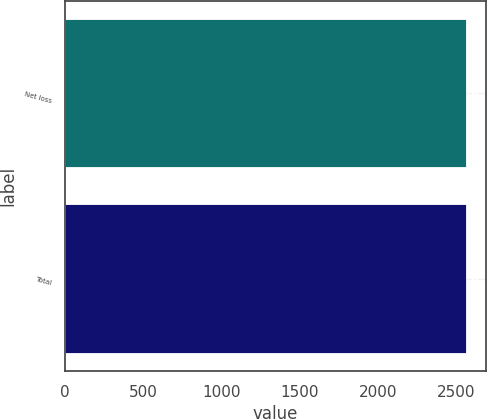Convert chart to OTSL. <chart><loc_0><loc_0><loc_500><loc_500><bar_chart><fcel>Net loss<fcel>Total<nl><fcel>2563<fcel>2563.1<nl></chart> 